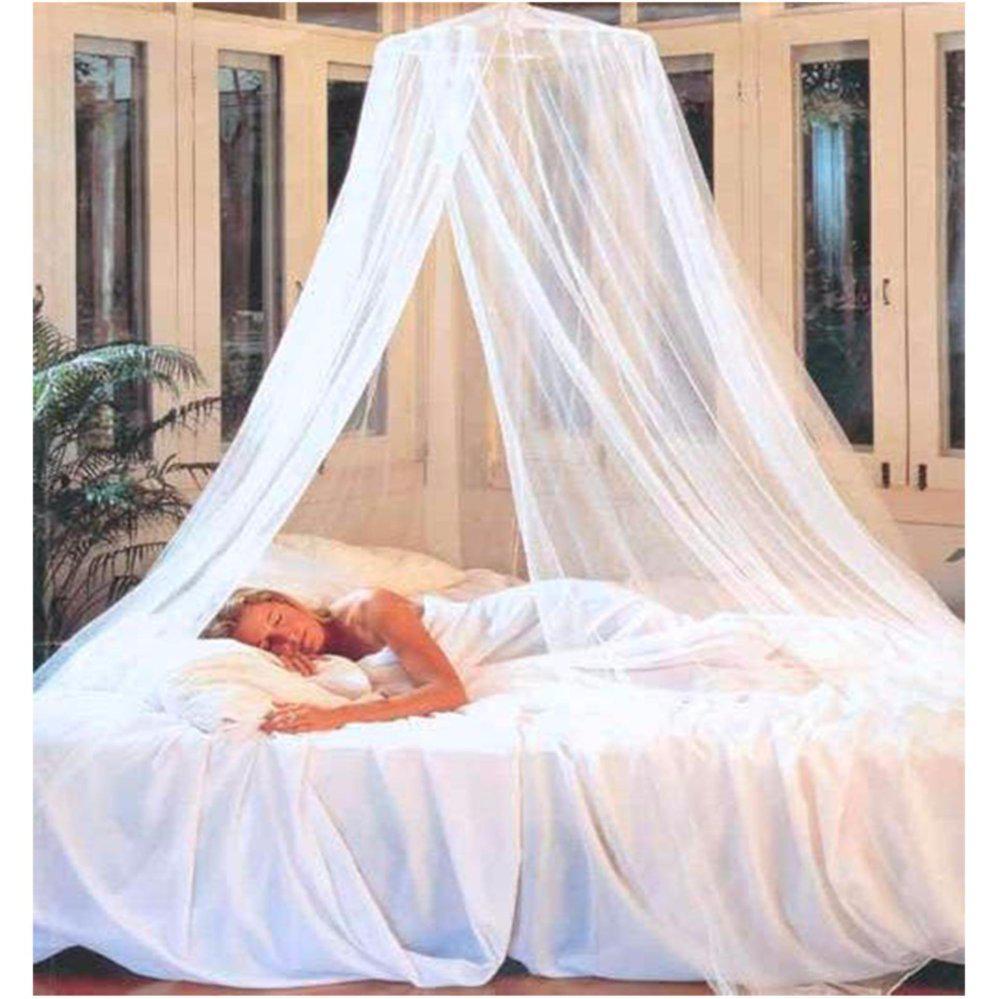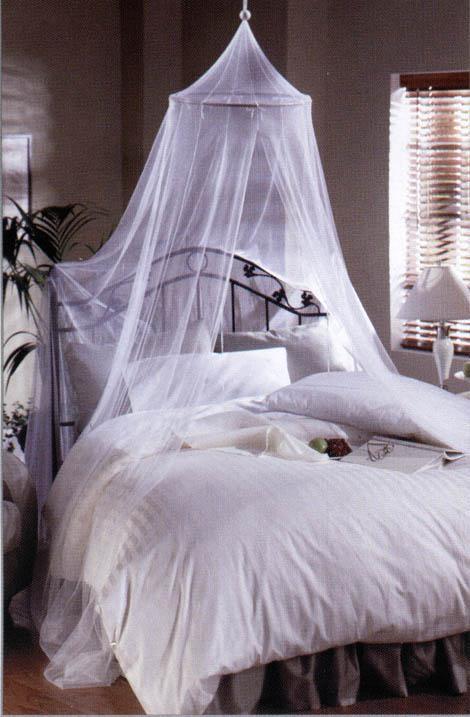The first image is the image on the left, the second image is the image on the right. For the images displayed, is the sentence "All bed drapery is hanging from a central point above a bed." factually correct? Answer yes or no. Yes. 